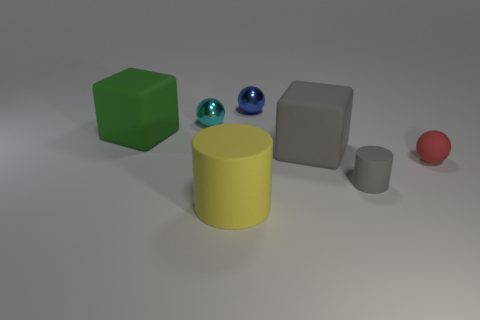Add 1 red rubber things. How many objects exist? 8 Subtract all cubes. How many objects are left? 5 Subtract 0 yellow spheres. How many objects are left? 7 Subtract all red things. Subtract all large green matte things. How many objects are left? 5 Add 6 cyan balls. How many cyan balls are left? 7 Add 7 yellow metallic balls. How many yellow metallic balls exist? 7 